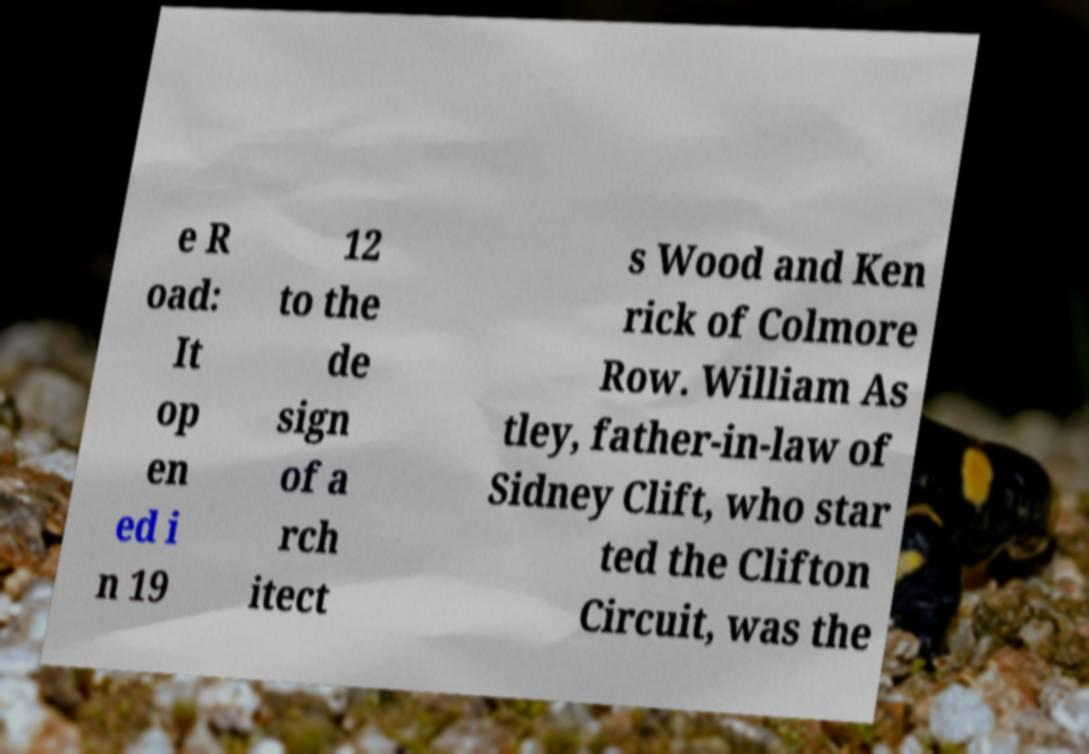For documentation purposes, I need the text within this image transcribed. Could you provide that? e R oad: It op en ed i n 19 12 to the de sign of a rch itect s Wood and Ken rick of Colmore Row. William As tley, father-in-law of Sidney Clift, who star ted the Clifton Circuit, was the 